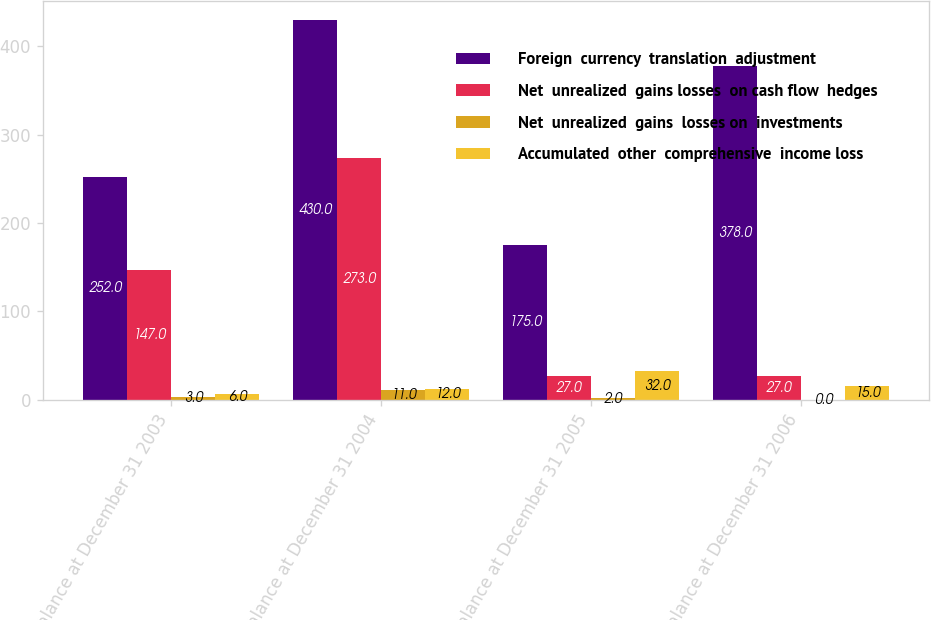Convert chart to OTSL. <chart><loc_0><loc_0><loc_500><loc_500><stacked_bar_chart><ecel><fcel>Balance at December 31 2003<fcel>Balance at December 31 2004<fcel>Balance at December 31 2005<fcel>Balance at December 31 2006<nl><fcel>Foreign  currency  translation  adjustment<fcel>252<fcel>430<fcel>175<fcel>378<nl><fcel>Net  unrealized  gains losses  on cash flow  hedges<fcel>147<fcel>273<fcel>27<fcel>27<nl><fcel>Net  unrealized  gains  losses on  investments<fcel>3<fcel>11<fcel>2<fcel>0<nl><fcel>Accumulated  other  comprehensive  income loss<fcel>6<fcel>12<fcel>32<fcel>15<nl></chart> 